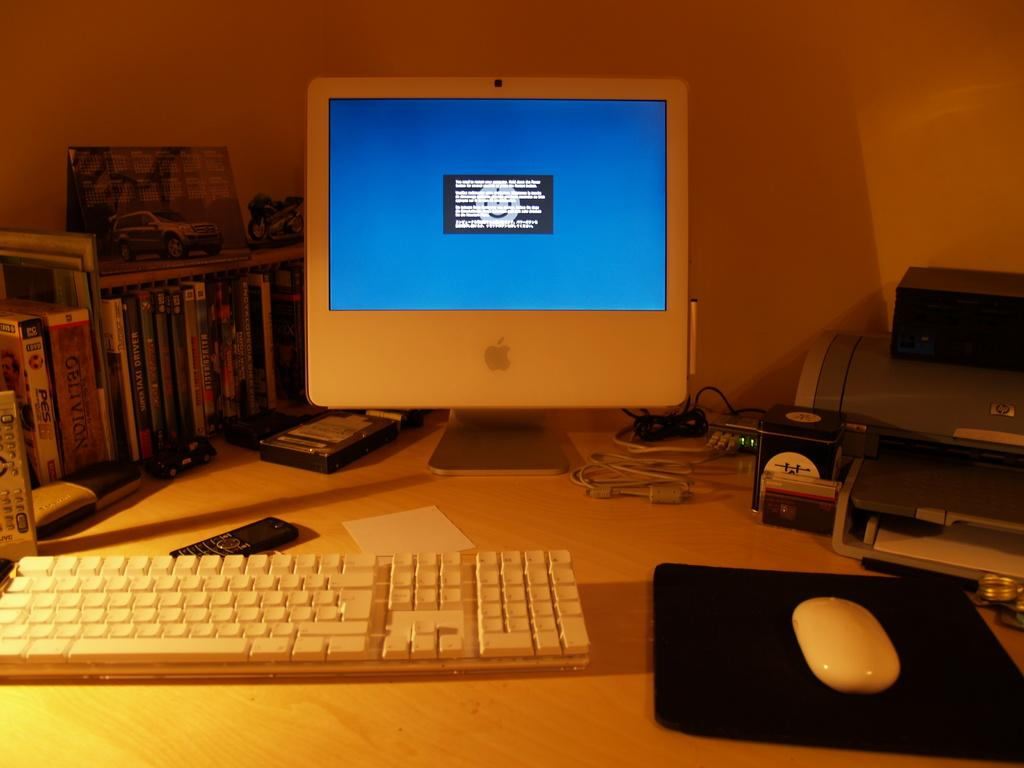What objects are present on the table in the image? There are books, a remote controller, a mobile phone, a keyboard, a monitor, a mouse, and a printer on the table in the image. What type of device is used for input in the image? The keyboard is used for input in the image. What type of device is used for display in the image? The monitor is used for display in the image. What type of device is used for printing in the image? The printer is used for printing in the image. What type of arithmetic problem can be solved using the books in the image? The image does not show any arithmetic problems or solutions; it only shows books on the table. How many ants are crawling on the remote controller in the image? There are no ants present in the image; the remote controller is the only object mentioned on the table. 